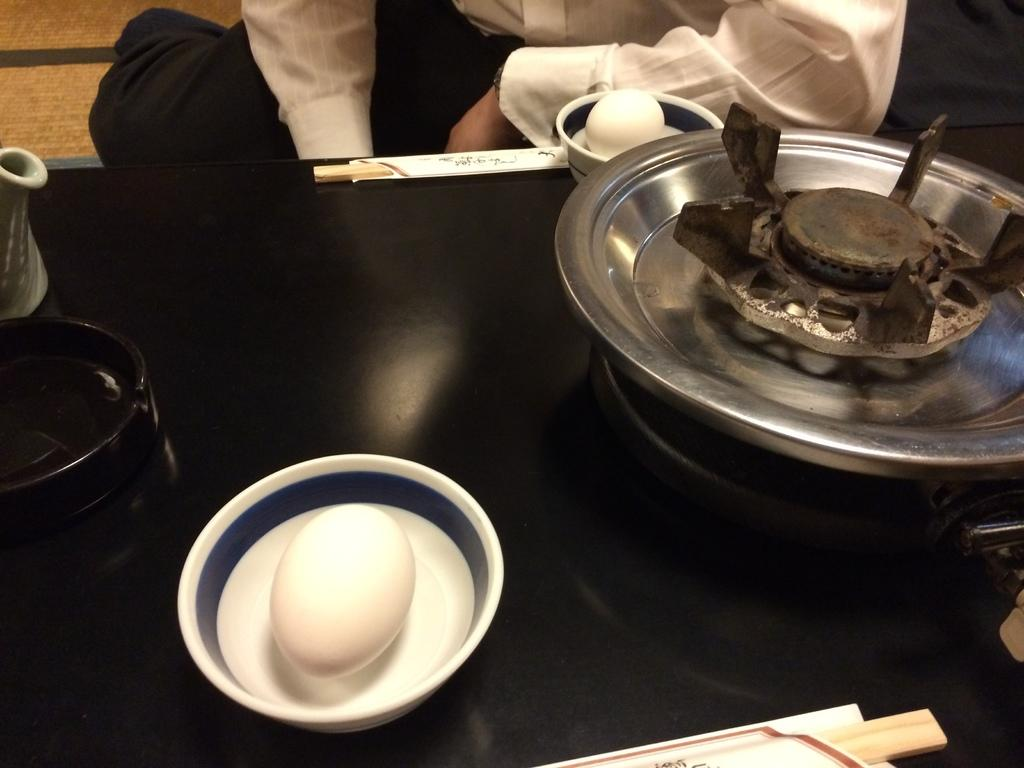What is present in the bowls in the image? There are eggs in bowls in the image. Can you describe the color of any object in the image? There is an object with a black color in the image. Who is visible in the image? There is a person visible in the image. What is the person wearing? The person is wearing a white and black dress. What type of event is the person attending in the image? There is no indication of an event in the image; it only shows eggs in bowls, a black object, and a person wearing a white and black dress. What type of thread is being used by the person in the image? There is no thread visible in the image, nor is there any indication that the person is using thread for any purpose. 